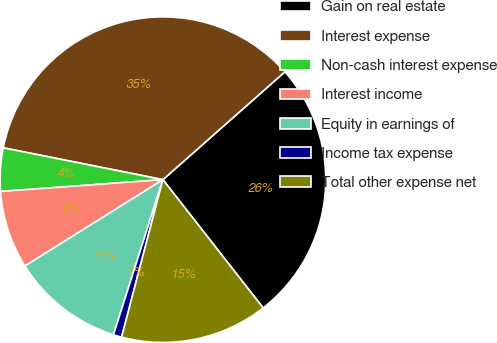Convert chart. <chart><loc_0><loc_0><loc_500><loc_500><pie_chart><fcel>Gain on real estate<fcel>Interest expense<fcel>Non-cash interest expense<fcel>Interest income<fcel>Equity in earnings of<fcel>Income tax expense<fcel>Total other expense net<nl><fcel>25.97%<fcel>35.35%<fcel>4.29%<fcel>7.74%<fcel>11.19%<fcel>0.83%<fcel>14.64%<nl></chart> 